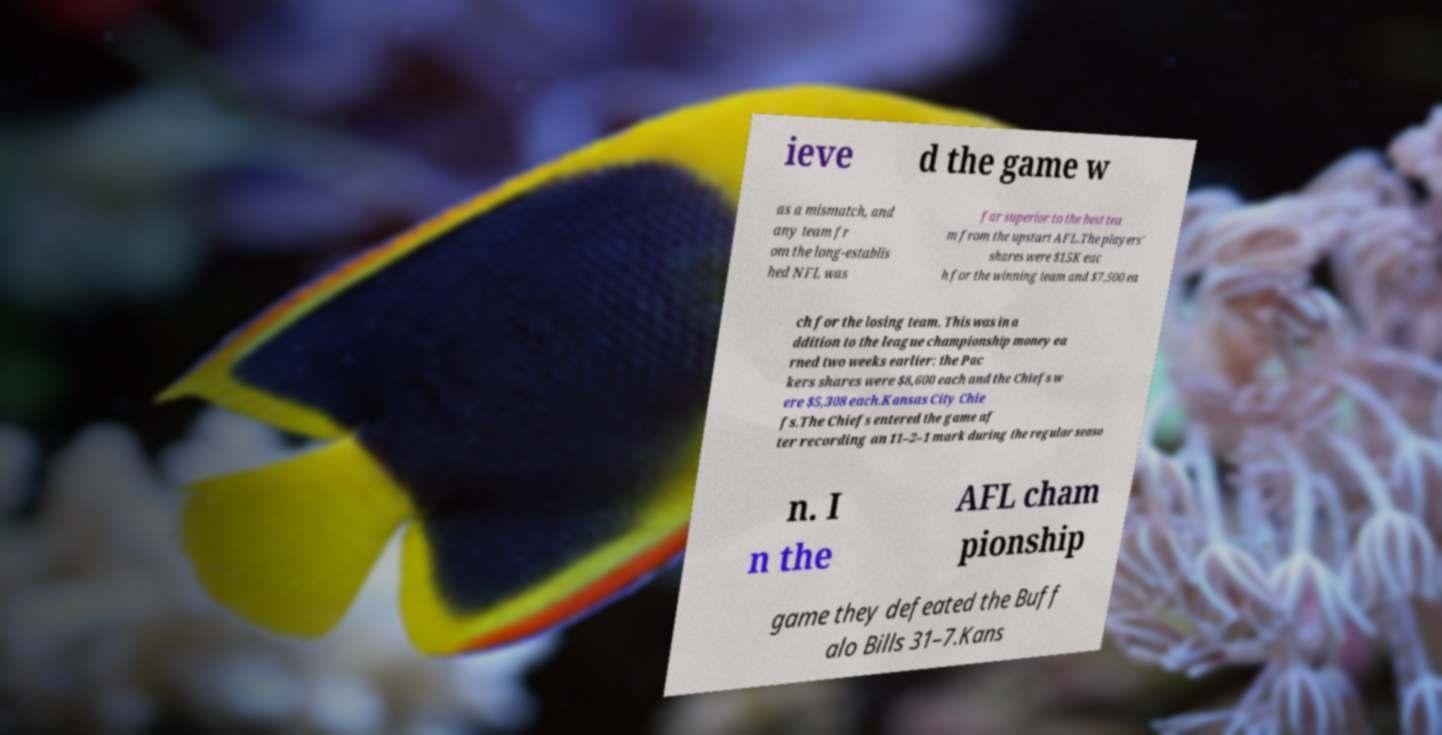Please read and relay the text visible in this image. What does it say? ieve d the game w as a mismatch, and any team fr om the long-establis hed NFL was far superior to the best tea m from the upstart AFL.The players' shares were $15K eac h for the winning team and $7,500 ea ch for the losing team. This was in a ddition to the league championship money ea rned two weeks earlier: the Pac kers shares were $8,600 each and the Chiefs w ere $5,308 each.Kansas City Chie fs.The Chiefs entered the game af ter recording an 11–2–1 mark during the regular seaso n. I n the AFL cham pionship game they defeated the Buff alo Bills 31–7.Kans 